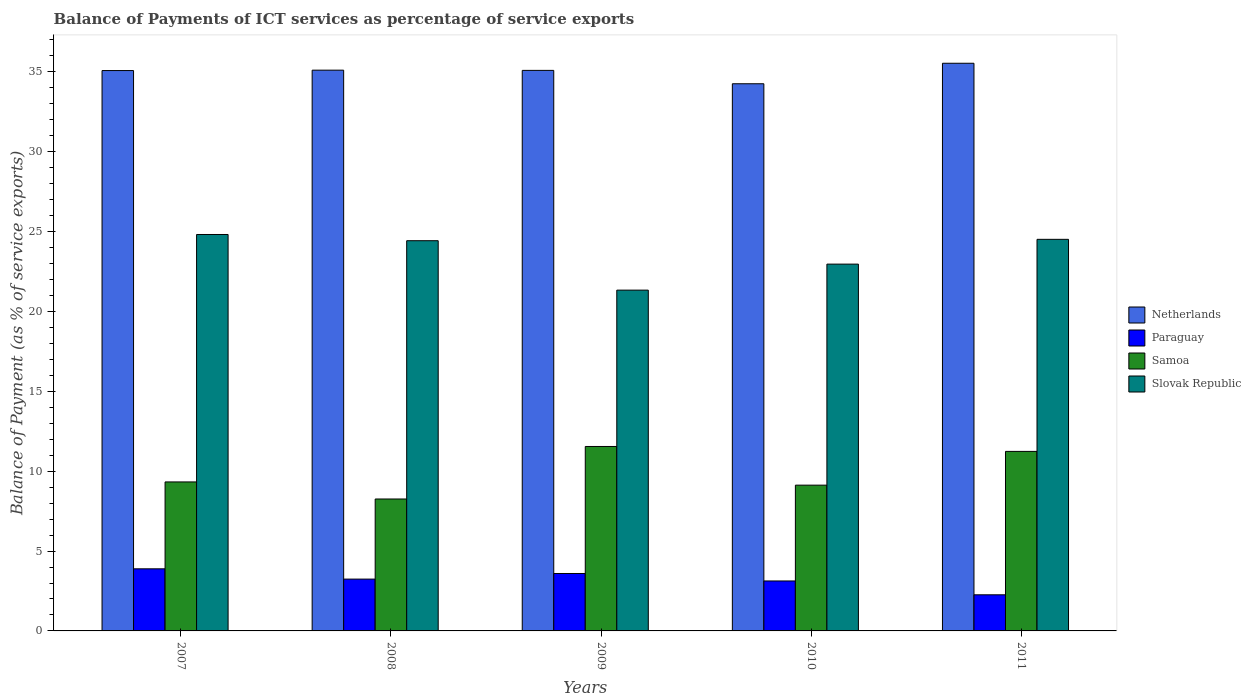How many different coloured bars are there?
Provide a short and direct response. 4. How many groups of bars are there?
Your answer should be very brief. 5. Are the number of bars per tick equal to the number of legend labels?
Provide a succinct answer. Yes. How many bars are there on the 1st tick from the left?
Give a very brief answer. 4. How many bars are there on the 1st tick from the right?
Make the answer very short. 4. In how many cases, is the number of bars for a given year not equal to the number of legend labels?
Ensure brevity in your answer.  0. What is the balance of payments of ICT services in Paraguay in 2011?
Provide a succinct answer. 2.26. Across all years, what is the maximum balance of payments of ICT services in Netherlands?
Your answer should be compact. 35.54. Across all years, what is the minimum balance of payments of ICT services in Paraguay?
Your answer should be compact. 2.26. What is the total balance of payments of ICT services in Slovak Republic in the graph?
Make the answer very short. 118.06. What is the difference between the balance of payments of ICT services in Samoa in 2008 and that in 2010?
Offer a terse response. -0.87. What is the difference between the balance of payments of ICT services in Paraguay in 2010 and the balance of payments of ICT services in Netherlands in 2009?
Keep it short and to the point. -31.96. What is the average balance of payments of ICT services in Samoa per year?
Your response must be concise. 9.9. In the year 2007, what is the difference between the balance of payments of ICT services in Paraguay and balance of payments of ICT services in Slovak Republic?
Your answer should be compact. -20.93. In how many years, is the balance of payments of ICT services in Samoa greater than 1 %?
Your response must be concise. 5. What is the ratio of the balance of payments of ICT services in Paraguay in 2007 to that in 2011?
Offer a very short reply. 1.72. Is the balance of payments of ICT services in Netherlands in 2007 less than that in 2008?
Provide a succinct answer. Yes. Is the difference between the balance of payments of ICT services in Paraguay in 2009 and 2011 greater than the difference between the balance of payments of ICT services in Slovak Republic in 2009 and 2011?
Your response must be concise. Yes. What is the difference between the highest and the second highest balance of payments of ICT services in Paraguay?
Keep it short and to the point. 0.29. What is the difference between the highest and the lowest balance of payments of ICT services in Slovak Republic?
Your response must be concise. 3.48. Is the sum of the balance of payments of ICT services in Slovak Republic in 2010 and 2011 greater than the maximum balance of payments of ICT services in Samoa across all years?
Keep it short and to the point. Yes. Is it the case that in every year, the sum of the balance of payments of ICT services in Slovak Republic and balance of payments of ICT services in Paraguay is greater than the sum of balance of payments of ICT services in Netherlands and balance of payments of ICT services in Samoa?
Make the answer very short. No. What does the 4th bar from the left in 2011 represents?
Provide a succinct answer. Slovak Republic. What does the 3rd bar from the right in 2008 represents?
Provide a short and direct response. Paraguay. Is it the case that in every year, the sum of the balance of payments of ICT services in Netherlands and balance of payments of ICT services in Samoa is greater than the balance of payments of ICT services in Paraguay?
Ensure brevity in your answer.  Yes. Are all the bars in the graph horizontal?
Provide a succinct answer. No. How many years are there in the graph?
Provide a succinct answer. 5. Are the values on the major ticks of Y-axis written in scientific E-notation?
Make the answer very short. No. Does the graph contain any zero values?
Offer a very short reply. No. How many legend labels are there?
Provide a succinct answer. 4. How are the legend labels stacked?
Provide a succinct answer. Vertical. What is the title of the graph?
Your answer should be very brief. Balance of Payments of ICT services as percentage of service exports. What is the label or title of the X-axis?
Provide a succinct answer. Years. What is the label or title of the Y-axis?
Offer a terse response. Balance of Payment (as % of service exports). What is the Balance of Payment (as % of service exports) in Netherlands in 2007?
Provide a short and direct response. 35.08. What is the Balance of Payment (as % of service exports) of Paraguay in 2007?
Your answer should be compact. 3.89. What is the Balance of Payment (as % of service exports) of Samoa in 2007?
Your answer should be very brief. 9.33. What is the Balance of Payment (as % of service exports) in Slovak Republic in 2007?
Your response must be concise. 24.82. What is the Balance of Payment (as % of service exports) of Netherlands in 2008?
Your response must be concise. 35.11. What is the Balance of Payment (as % of service exports) in Paraguay in 2008?
Offer a terse response. 3.24. What is the Balance of Payment (as % of service exports) of Samoa in 2008?
Make the answer very short. 8.26. What is the Balance of Payment (as % of service exports) of Slovak Republic in 2008?
Make the answer very short. 24.43. What is the Balance of Payment (as % of service exports) of Netherlands in 2009?
Provide a short and direct response. 35.09. What is the Balance of Payment (as % of service exports) of Paraguay in 2009?
Ensure brevity in your answer.  3.59. What is the Balance of Payment (as % of service exports) of Samoa in 2009?
Offer a terse response. 11.55. What is the Balance of Payment (as % of service exports) of Slovak Republic in 2009?
Provide a short and direct response. 21.33. What is the Balance of Payment (as % of service exports) of Netherlands in 2010?
Provide a short and direct response. 34.25. What is the Balance of Payment (as % of service exports) of Paraguay in 2010?
Your answer should be very brief. 3.13. What is the Balance of Payment (as % of service exports) in Samoa in 2010?
Ensure brevity in your answer.  9.13. What is the Balance of Payment (as % of service exports) of Slovak Republic in 2010?
Offer a very short reply. 22.96. What is the Balance of Payment (as % of service exports) of Netherlands in 2011?
Offer a terse response. 35.54. What is the Balance of Payment (as % of service exports) in Paraguay in 2011?
Your answer should be compact. 2.26. What is the Balance of Payment (as % of service exports) in Samoa in 2011?
Your answer should be very brief. 11.24. What is the Balance of Payment (as % of service exports) in Slovak Republic in 2011?
Your response must be concise. 24.51. Across all years, what is the maximum Balance of Payment (as % of service exports) in Netherlands?
Make the answer very short. 35.54. Across all years, what is the maximum Balance of Payment (as % of service exports) of Paraguay?
Your answer should be very brief. 3.89. Across all years, what is the maximum Balance of Payment (as % of service exports) of Samoa?
Offer a terse response. 11.55. Across all years, what is the maximum Balance of Payment (as % of service exports) of Slovak Republic?
Offer a terse response. 24.82. Across all years, what is the minimum Balance of Payment (as % of service exports) in Netherlands?
Offer a terse response. 34.25. Across all years, what is the minimum Balance of Payment (as % of service exports) in Paraguay?
Keep it short and to the point. 2.26. Across all years, what is the minimum Balance of Payment (as % of service exports) in Samoa?
Provide a succinct answer. 8.26. Across all years, what is the minimum Balance of Payment (as % of service exports) in Slovak Republic?
Offer a very short reply. 21.33. What is the total Balance of Payment (as % of service exports) of Netherlands in the graph?
Give a very brief answer. 175.07. What is the total Balance of Payment (as % of service exports) in Paraguay in the graph?
Ensure brevity in your answer.  16.11. What is the total Balance of Payment (as % of service exports) in Samoa in the graph?
Make the answer very short. 49.5. What is the total Balance of Payment (as % of service exports) in Slovak Republic in the graph?
Offer a very short reply. 118.06. What is the difference between the Balance of Payment (as % of service exports) of Netherlands in 2007 and that in 2008?
Offer a terse response. -0.02. What is the difference between the Balance of Payment (as % of service exports) of Paraguay in 2007 and that in 2008?
Provide a short and direct response. 0.64. What is the difference between the Balance of Payment (as % of service exports) in Samoa in 2007 and that in 2008?
Provide a short and direct response. 1.07. What is the difference between the Balance of Payment (as % of service exports) in Slovak Republic in 2007 and that in 2008?
Offer a very short reply. 0.39. What is the difference between the Balance of Payment (as % of service exports) of Netherlands in 2007 and that in 2009?
Your answer should be very brief. -0.01. What is the difference between the Balance of Payment (as % of service exports) of Paraguay in 2007 and that in 2009?
Offer a terse response. 0.29. What is the difference between the Balance of Payment (as % of service exports) of Samoa in 2007 and that in 2009?
Provide a short and direct response. -2.22. What is the difference between the Balance of Payment (as % of service exports) in Slovak Republic in 2007 and that in 2009?
Offer a very short reply. 3.48. What is the difference between the Balance of Payment (as % of service exports) of Netherlands in 2007 and that in 2010?
Keep it short and to the point. 0.83. What is the difference between the Balance of Payment (as % of service exports) of Paraguay in 2007 and that in 2010?
Your response must be concise. 0.76. What is the difference between the Balance of Payment (as % of service exports) of Samoa in 2007 and that in 2010?
Provide a short and direct response. 0.2. What is the difference between the Balance of Payment (as % of service exports) of Slovak Republic in 2007 and that in 2010?
Your answer should be very brief. 1.85. What is the difference between the Balance of Payment (as % of service exports) in Netherlands in 2007 and that in 2011?
Provide a succinct answer. -0.46. What is the difference between the Balance of Payment (as % of service exports) of Paraguay in 2007 and that in 2011?
Your answer should be compact. 1.63. What is the difference between the Balance of Payment (as % of service exports) of Samoa in 2007 and that in 2011?
Keep it short and to the point. -1.91. What is the difference between the Balance of Payment (as % of service exports) of Slovak Republic in 2007 and that in 2011?
Your response must be concise. 0.3. What is the difference between the Balance of Payment (as % of service exports) of Netherlands in 2008 and that in 2009?
Your answer should be very brief. 0.01. What is the difference between the Balance of Payment (as % of service exports) of Paraguay in 2008 and that in 2009?
Offer a very short reply. -0.35. What is the difference between the Balance of Payment (as % of service exports) in Samoa in 2008 and that in 2009?
Offer a very short reply. -3.29. What is the difference between the Balance of Payment (as % of service exports) of Slovak Republic in 2008 and that in 2009?
Provide a short and direct response. 3.09. What is the difference between the Balance of Payment (as % of service exports) in Netherlands in 2008 and that in 2010?
Your response must be concise. 0.85. What is the difference between the Balance of Payment (as % of service exports) in Paraguay in 2008 and that in 2010?
Give a very brief answer. 0.12. What is the difference between the Balance of Payment (as % of service exports) in Samoa in 2008 and that in 2010?
Your answer should be very brief. -0.87. What is the difference between the Balance of Payment (as % of service exports) in Slovak Republic in 2008 and that in 2010?
Ensure brevity in your answer.  1.47. What is the difference between the Balance of Payment (as % of service exports) in Netherlands in 2008 and that in 2011?
Offer a terse response. -0.43. What is the difference between the Balance of Payment (as % of service exports) in Paraguay in 2008 and that in 2011?
Make the answer very short. 0.98. What is the difference between the Balance of Payment (as % of service exports) of Samoa in 2008 and that in 2011?
Make the answer very short. -2.98. What is the difference between the Balance of Payment (as % of service exports) of Slovak Republic in 2008 and that in 2011?
Make the answer very short. -0.09. What is the difference between the Balance of Payment (as % of service exports) in Netherlands in 2009 and that in 2010?
Give a very brief answer. 0.84. What is the difference between the Balance of Payment (as % of service exports) in Paraguay in 2009 and that in 2010?
Your answer should be very brief. 0.47. What is the difference between the Balance of Payment (as % of service exports) in Samoa in 2009 and that in 2010?
Your response must be concise. 2.42. What is the difference between the Balance of Payment (as % of service exports) in Slovak Republic in 2009 and that in 2010?
Make the answer very short. -1.63. What is the difference between the Balance of Payment (as % of service exports) of Netherlands in 2009 and that in 2011?
Your response must be concise. -0.45. What is the difference between the Balance of Payment (as % of service exports) of Paraguay in 2009 and that in 2011?
Keep it short and to the point. 1.33. What is the difference between the Balance of Payment (as % of service exports) in Samoa in 2009 and that in 2011?
Provide a short and direct response. 0.31. What is the difference between the Balance of Payment (as % of service exports) of Slovak Republic in 2009 and that in 2011?
Keep it short and to the point. -3.18. What is the difference between the Balance of Payment (as % of service exports) in Netherlands in 2010 and that in 2011?
Offer a terse response. -1.28. What is the difference between the Balance of Payment (as % of service exports) in Paraguay in 2010 and that in 2011?
Provide a succinct answer. 0.87. What is the difference between the Balance of Payment (as % of service exports) of Samoa in 2010 and that in 2011?
Provide a short and direct response. -2.11. What is the difference between the Balance of Payment (as % of service exports) of Slovak Republic in 2010 and that in 2011?
Make the answer very short. -1.55. What is the difference between the Balance of Payment (as % of service exports) in Netherlands in 2007 and the Balance of Payment (as % of service exports) in Paraguay in 2008?
Your answer should be very brief. 31.84. What is the difference between the Balance of Payment (as % of service exports) of Netherlands in 2007 and the Balance of Payment (as % of service exports) of Samoa in 2008?
Keep it short and to the point. 26.82. What is the difference between the Balance of Payment (as % of service exports) of Netherlands in 2007 and the Balance of Payment (as % of service exports) of Slovak Republic in 2008?
Your answer should be very brief. 10.65. What is the difference between the Balance of Payment (as % of service exports) in Paraguay in 2007 and the Balance of Payment (as % of service exports) in Samoa in 2008?
Offer a very short reply. -4.37. What is the difference between the Balance of Payment (as % of service exports) of Paraguay in 2007 and the Balance of Payment (as % of service exports) of Slovak Republic in 2008?
Your answer should be very brief. -20.54. What is the difference between the Balance of Payment (as % of service exports) of Samoa in 2007 and the Balance of Payment (as % of service exports) of Slovak Republic in 2008?
Give a very brief answer. -15.1. What is the difference between the Balance of Payment (as % of service exports) of Netherlands in 2007 and the Balance of Payment (as % of service exports) of Paraguay in 2009?
Offer a very short reply. 31.49. What is the difference between the Balance of Payment (as % of service exports) in Netherlands in 2007 and the Balance of Payment (as % of service exports) in Samoa in 2009?
Provide a succinct answer. 23.53. What is the difference between the Balance of Payment (as % of service exports) of Netherlands in 2007 and the Balance of Payment (as % of service exports) of Slovak Republic in 2009?
Provide a short and direct response. 13.75. What is the difference between the Balance of Payment (as % of service exports) in Paraguay in 2007 and the Balance of Payment (as % of service exports) in Samoa in 2009?
Your response must be concise. -7.66. What is the difference between the Balance of Payment (as % of service exports) of Paraguay in 2007 and the Balance of Payment (as % of service exports) of Slovak Republic in 2009?
Your response must be concise. -17.45. What is the difference between the Balance of Payment (as % of service exports) in Samoa in 2007 and the Balance of Payment (as % of service exports) in Slovak Republic in 2009?
Provide a short and direct response. -12.01. What is the difference between the Balance of Payment (as % of service exports) in Netherlands in 2007 and the Balance of Payment (as % of service exports) in Paraguay in 2010?
Provide a succinct answer. 31.95. What is the difference between the Balance of Payment (as % of service exports) in Netherlands in 2007 and the Balance of Payment (as % of service exports) in Samoa in 2010?
Provide a short and direct response. 25.96. What is the difference between the Balance of Payment (as % of service exports) of Netherlands in 2007 and the Balance of Payment (as % of service exports) of Slovak Republic in 2010?
Provide a succinct answer. 12.12. What is the difference between the Balance of Payment (as % of service exports) in Paraguay in 2007 and the Balance of Payment (as % of service exports) in Samoa in 2010?
Your answer should be compact. -5.24. What is the difference between the Balance of Payment (as % of service exports) of Paraguay in 2007 and the Balance of Payment (as % of service exports) of Slovak Republic in 2010?
Offer a very short reply. -19.08. What is the difference between the Balance of Payment (as % of service exports) of Samoa in 2007 and the Balance of Payment (as % of service exports) of Slovak Republic in 2010?
Offer a very short reply. -13.64. What is the difference between the Balance of Payment (as % of service exports) of Netherlands in 2007 and the Balance of Payment (as % of service exports) of Paraguay in 2011?
Provide a succinct answer. 32.82. What is the difference between the Balance of Payment (as % of service exports) of Netherlands in 2007 and the Balance of Payment (as % of service exports) of Samoa in 2011?
Your answer should be very brief. 23.84. What is the difference between the Balance of Payment (as % of service exports) of Netherlands in 2007 and the Balance of Payment (as % of service exports) of Slovak Republic in 2011?
Your response must be concise. 10.57. What is the difference between the Balance of Payment (as % of service exports) in Paraguay in 2007 and the Balance of Payment (as % of service exports) in Samoa in 2011?
Your answer should be compact. -7.35. What is the difference between the Balance of Payment (as % of service exports) in Paraguay in 2007 and the Balance of Payment (as % of service exports) in Slovak Republic in 2011?
Give a very brief answer. -20.63. What is the difference between the Balance of Payment (as % of service exports) in Samoa in 2007 and the Balance of Payment (as % of service exports) in Slovak Republic in 2011?
Offer a terse response. -15.19. What is the difference between the Balance of Payment (as % of service exports) of Netherlands in 2008 and the Balance of Payment (as % of service exports) of Paraguay in 2009?
Your answer should be very brief. 31.51. What is the difference between the Balance of Payment (as % of service exports) of Netherlands in 2008 and the Balance of Payment (as % of service exports) of Samoa in 2009?
Give a very brief answer. 23.56. What is the difference between the Balance of Payment (as % of service exports) of Netherlands in 2008 and the Balance of Payment (as % of service exports) of Slovak Republic in 2009?
Provide a succinct answer. 13.77. What is the difference between the Balance of Payment (as % of service exports) of Paraguay in 2008 and the Balance of Payment (as % of service exports) of Samoa in 2009?
Offer a terse response. -8.3. What is the difference between the Balance of Payment (as % of service exports) in Paraguay in 2008 and the Balance of Payment (as % of service exports) in Slovak Republic in 2009?
Ensure brevity in your answer.  -18.09. What is the difference between the Balance of Payment (as % of service exports) in Samoa in 2008 and the Balance of Payment (as % of service exports) in Slovak Republic in 2009?
Your answer should be very brief. -13.08. What is the difference between the Balance of Payment (as % of service exports) in Netherlands in 2008 and the Balance of Payment (as % of service exports) in Paraguay in 2010?
Your response must be concise. 31.98. What is the difference between the Balance of Payment (as % of service exports) of Netherlands in 2008 and the Balance of Payment (as % of service exports) of Samoa in 2010?
Make the answer very short. 25.98. What is the difference between the Balance of Payment (as % of service exports) in Netherlands in 2008 and the Balance of Payment (as % of service exports) in Slovak Republic in 2010?
Provide a succinct answer. 12.14. What is the difference between the Balance of Payment (as % of service exports) of Paraguay in 2008 and the Balance of Payment (as % of service exports) of Samoa in 2010?
Your answer should be very brief. -5.88. What is the difference between the Balance of Payment (as % of service exports) in Paraguay in 2008 and the Balance of Payment (as % of service exports) in Slovak Republic in 2010?
Provide a succinct answer. -19.72. What is the difference between the Balance of Payment (as % of service exports) of Samoa in 2008 and the Balance of Payment (as % of service exports) of Slovak Republic in 2010?
Your answer should be very brief. -14.7. What is the difference between the Balance of Payment (as % of service exports) of Netherlands in 2008 and the Balance of Payment (as % of service exports) of Paraguay in 2011?
Offer a very short reply. 32.84. What is the difference between the Balance of Payment (as % of service exports) in Netherlands in 2008 and the Balance of Payment (as % of service exports) in Samoa in 2011?
Keep it short and to the point. 23.87. What is the difference between the Balance of Payment (as % of service exports) of Netherlands in 2008 and the Balance of Payment (as % of service exports) of Slovak Republic in 2011?
Offer a terse response. 10.59. What is the difference between the Balance of Payment (as % of service exports) in Paraguay in 2008 and the Balance of Payment (as % of service exports) in Samoa in 2011?
Keep it short and to the point. -7.99. What is the difference between the Balance of Payment (as % of service exports) of Paraguay in 2008 and the Balance of Payment (as % of service exports) of Slovak Republic in 2011?
Ensure brevity in your answer.  -21.27. What is the difference between the Balance of Payment (as % of service exports) of Samoa in 2008 and the Balance of Payment (as % of service exports) of Slovak Republic in 2011?
Ensure brevity in your answer.  -16.26. What is the difference between the Balance of Payment (as % of service exports) in Netherlands in 2009 and the Balance of Payment (as % of service exports) in Paraguay in 2010?
Make the answer very short. 31.96. What is the difference between the Balance of Payment (as % of service exports) of Netherlands in 2009 and the Balance of Payment (as % of service exports) of Samoa in 2010?
Offer a terse response. 25.97. What is the difference between the Balance of Payment (as % of service exports) in Netherlands in 2009 and the Balance of Payment (as % of service exports) in Slovak Republic in 2010?
Provide a succinct answer. 12.13. What is the difference between the Balance of Payment (as % of service exports) of Paraguay in 2009 and the Balance of Payment (as % of service exports) of Samoa in 2010?
Your answer should be compact. -5.53. What is the difference between the Balance of Payment (as % of service exports) of Paraguay in 2009 and the Balance of Payment (as % of service exports) of Slovak Republic in 2010?
Offer a very short reply. -19.37. What is the difference between the Balance of Payment (as % of service exports) in Samoa in 2009 and the Balance of Payment (as % of service exports) in Slovak Republic in 2010?
Offer a very short reply. -11.42. What is the difference between the Balance of Payment (as % of service exports) of Netherlands in 2009 and the Balance of Payment (as % of service exports) of Paraguay in 2011?
Your answer should be compact. 32.83. What is the difference between the Balance of Payment (as % of service exports) of Netherlands in 2009 and the Balance of Payment (as % of service exports) of Samoa in 2011?
Keep it short and to the point. 23.85. What is the difference between the Balance of Payment (as % of service exports) of Netherlands in 2009 and the Balance of Payment (as % of service exports) of Slovak Republic in 2011?
Offer a very short reply. 10.58. What is the difference between the Balance of Payment (as % of service exports) in Paraguay in 2009 and the Balance of Payment (as % of service exports) in Samoa in 2011?
Provide a short and direct response. -7.64. What is the difference between the Balance of Payment (as % of service exports) in Paraguay in 2009 and the Balance of Payment (as % of service exports) in Slovak Republic in 2011?
Offer a terse response. -20.92. What is the difference between the Balance of Payment (as % of service exports) in Samoa in 2009 and the Balance of Payment (as % of service exports) in Slovak Republic in 2011?
Your answer should be very brief. -12.97. What is the difference between the Balance of Payment (as % of service exports) of Netherlands in 2010 and the Balance of Payment (as % of service exports) of Paraguay in 2011?
Your response must be concise. 31.99. What is the difference between the Balance of Payment (as % of service exports) of Netherlands in 2010 and the Balance of Payment (as % of service exports) of Samoa in 2011?
Your answer should be very brief. 23.02. What is the difference between the Balance of Payment (as % of service exports) of Netherlands in 2010 and the Balance of Payment (as % of service exports) of Slovak Republic in 2011?
Your response must be concise. 9.74. What is the difference between the Balance of Payment (as % of service exports) of Paraguay in 2010 and the Balance of Payment (as % of service exports) of Samoa in 2011?
Ensure brevity in your answer.  -8.11. What is the difference between the Balance of Payment (as % of service exports) of Paraguay in 2010 and the Balance of Payment (as % of service exports) of Slovak Republic in 2011?
Make the answer very short. -21.39. What is the difference between the Balance of Payment (as % of service exports) of Samoa in 2010 and the Balance of Payment (as % of service exports) of Slovak Republic in 2011?
Provide a short and direct response. -15.39. What is the average Balance of Payment (as % of service exports) of Netherlands per year?
Give a very brief answer. 35.01. What is the average Balance of Payment (as % of service exports) of Paraguay per year?
Keep it short and to the point. 3.22. What is the average Balance of Payment (as % of service exports) in Samoa per year?
Offer a terse response. 9.9. What is the average Balance of Payment (as % of service exports) of Slovak Republic per year?
Make the answer very short. 23.61. In the year 2007, what is the difference between the Balance of Payment (as % of service exports) of Netherlands and Balance of Payment (as % of service exports) of Paraguay?
Your answer should be compact. 31.19. In the year 2007, what is the difference between the Balance of Payment (as % of service exports) in Netherlands and Balance of Payment (as % of service exports) in Samoa?
Provide a succinct answer. 25.75. In the year 2007, what is the difference between the Balance of Payment (as % of service exports) in Netherlands and Balance of Payment (as % of service exports) in Slovak Republic?
Offer a very short reply. 10.26. In the year 2007, what is the difference between the Balance of Payment (as % of service exports) of Paraguay and Balance of Payment (as % of service exports) of Samoa?
Ensure brevity in your answer.  -5.44. In the year 2007, what is the difference between the Balance of Payment (as % of service exports) of Paraguay and Balance of Payment (as % of service exports) of Slovak Republic?
Provide a short and direct response. -20.93. In the year 2007, what is the difference between the Balance of Payment (as % of service exports) in Samoa and Balance of Payment (as % of service exports) in Slovak Republic?
Offer a terse response. -15.49. In the year 2008, what is the difference between the Balance of Payment (as % of service exports) of Netherlands and Balance of Payment (as % of service exports) of Paraguay?
Your answer should be compact. 31.86. In the year 2008, what is the difference between the Balance of Payment (as % of service exports) of Netherlands and Balance of Payment (as % of service exports) of Samoa?
Your response must be concise. 26.85. In the year 2008, what is the difference between the Balance of Payment (as % of service exports) in Netherlands and Balance of Payment (as % of service exports) in Slovak Republic?
Ensure brevity in your answer.  10.68. In the year 2008, what is the difference between the Balance of Payment (as % of service exports) in Paraguay and Balance of Payment (as % of service exports) in Samoa?
Your answer should be very brief. -5.02. In the year 2008, what is the difference between the Balance of Payment (as % of service exports) of Paraguay and Balance of Payment (as % of service exports) of Slovak Republic?
Ensure brevity in your answer.  -21.19. In the year 2008, what is the difference between the Balance of Payment (as % of service exports) of Samoa and Balance of Payment (as % of service exports) of Slovak Republic?
Provide a succinct answer. -16.17. In the year 2009, what is the difference between the Balance of Payment (as % of service exports) in Netherlands and Balance of Payment (as % of service exports) in Paraguay?
Provide a short and direct response. 31.5. In the year 2009, what is the difference between the Balance of Payment (as % of service exports) in Netherlands and Balance of Payment (as % of service exports) in Samoa?
Offer a terse response. 23.55. In the year 2009, what is the difference between the Balance of Payment (as % of service exports) of Netherlands and Balance of Payment (as % of service exports) of Slovak Republic?
Provide a succinct answer. 13.76. In the year 2009, what is the difference between the Balance of Payment (as % of service exports) of Paraguay and Balance of Payment (as % of service exports) of Samoa?
Offer a very short reply. -7.95. In the year 2009, what is the difference between the Balance of Payment (as % of service exports) in Paraguay and Balance of Payment (as % of service exports) in Slovak Republic?
Provide a short and direct response. -17.74. In the year 2009, what is the difference between the Balance of Payment (as % of service exports) in Samoa and Balance of Payment (as % of service exports) in Slovak Republic?
Keep it short and to the point. -9.79. In the year 2010, what is the difference between the Balance of Payment (as % of service exports) of Netherlands and Balance of Payment (as % of service exports) of Paraguay?
Ensure brevity in your answer.  31.13. In the year 2010, what is the difference between the Balance of Payment (as % of service exports) of Netherlands and Balance of Payment (as % of service exports) of Samoa?
Ensure brevity in your answer.  25.13. In the year 2010, what is the difference between the Balance of Payment (as % of service exports) in Netherlands and Balance of Payment (as % of service exports) in Slovak Republic?
Provide a short and direct response. 11.29. In the year 2010, what is the difference between the Balance of Payment (as % of service exports) of Paraguay and Balance of Payment (as % of service exports) of Samoa?
Your answer should be compact. -6. In the year 2010, what is the difference between the Balance of Payment (as % of service exports) of Paraguay and Balance of Payment (as % of service exports) of Slovak Republic?
Give a very brief answer. -19.84. In the year 2010, what is the difference between the Balance of Payment (as % of service exports) of Samoa and Balance of Payment (as % of service exports) of Slovak Republic?
Keep it short and to the point. -13.84. In the year 2011, what is the difference between the Balance of Payment (as % of service exports) of Netherlands and Balance of Payment (as % of service exports) of Paraguay?
Ensure brevity in your answer.  33.28. In the year 2011, what is the difference between the Balance of Payment (as % of service exports) of Netherlands and Balance of Payment (as % of service exports) of Samoa?
Your answer should be very brief. 24.3. In the year 2011, what is the difference between the Balance of Payment (as % of service exports) in Netherlands and Balance of Payment (as % of service exports) in Slovak Republic?
Your answer should be compact. 11.02. In the year 2011, what is the difference between the Balance of Payment (as % of service exports) of Paraguay and Balance of Payment (as % of service exports) of Samoa?
Your answer should be compact. -8.98. In the year 2011, what is the difference between the Balance of Payment (as % of service exports) of Paraguay and Balance of Payment (as % of service exports) of Slovak Republic?
Offer a terse response. -22.25. In the year 2011, what is the difference between the Balance of Payment (as % of service exports) in Samoa and Balance of Payment (as % of service exports) in Slovak Republic?
Keep it short and to the point. -13.28. What is the ratio of the Balance of Payment (as % of service exports) of Netherlands in 2007 to that in 2008?
Keep it short and to the point. 1. What is the ratio of the Balance of Payment (as % of service exports) in Paraguay in 2007 to that in 2008?
Offer a very short reply. 1.2. What is the ratio of the Balance of Payment (as % of service exports) in Samoa in 2007 to that in 2008?
Your answer should be compact. 1.13. What is the ratio of the Balance of Payment (as % of service exports) of Slovak Republic in 2007 to that in 2008?
Keep it short and to the point. 1.02. What is the ratio of the Balance of Payment (as % of service exports) of Paraguay in 2007 to that in 2009?
Your answer should be compact. 1.08. What is the ratio of the Balance of Payment (as % of service exports) of Samoa in 2007 to that in 2009?
Keep it short and to the point. 0.81. What is the ratio of the Balance of Payment (as % of service exports) in Slovak Republic in 2007 to that in 2009?
Your answer should be compact. 1.16. What is the ratio of the Balance of Payment (as % of service exports) in Netherlands in 2007 to that in 2010?
Provide a succinct answer. 1.02. What is the ratio of the Balance of Payment (as % of service exports) in Paraguay in 2007 to that in 2010?
Make the answer very short. 1.24. What is the ratio of the Balance of Payment (as % of service exports) in Samoa in 2007 to that in 2010?
Your answer should be very brief. 1.02. What is the ratio of the Balance of Payment (as % of service exports) in Slovak Republic in 2007 to that in 2010?
Your answer should be compact. 1.08. What is the ratio of the Balance of Payment (as % of service exports) of Netherlands in 2007 to that in 2011?
Offer a terse response. 0.99. What is the ratio of the Balance of Payment (as % of service exports) of Paraguay in 2007 to that in 2011?
Keep it short and to the point. 1.72. What is the ratio of the Balance of Payment (as % of service exports) of Samoa in 2007 to that in 2011?
Offer a terse response. 0.83. What is the ratio of the Balance of Payment (as % of service exports) of Slovak Republic in 2007 to that in 2011?
Your response must be concise. 1.01. What is the ratio of the Balance of Payment (as % of service exports) of Paraguay in 2008 to that in 2009?
Provide a succinct answer. 0.9. What is the ratio of the Balance of Payment (as % of service exports) in Samoa in 2008 to that in 2009?
Give a very brief answer. 0.72. What is the ratio of the Balance of Payment (as % of service exports) in Slovak Republic in 2008 to that in 2009?
Offer a terse response. 1.15. What is the ratio of the Balance of Payment (as % of service exports) of Netherlands in 2008 to that in 2010?
Your answer should be compact. 1.02. What is the ratio of the Balance of Payment (as % of service exports) of Paraguay in 2008 to that in 2010?
Give a very brief answer. 1.04. What is the ratio of the Balance of Payment (as % of service exports) of Samoa in 2008 to that in 2010?
Your response must be concise. 0.91. What is the ratio of the Balance of Payment (as % of service exports) of Slovak Republic in 2008 to that in 2010?
Ensure brevity in your answer.  1.06. What is the ratio of the Balance of Payment (as % of service exports) of Paraguay in 2008 to that in 2011?
Make the answer very short. 1.43. What is the ratio of the Balance of Payment (as % of service exports) in Samoa in 2008 to that in 2011?
Make the answer very short. 0.73. What is the ratio of the Balance of Payment (as % of service exports) in Slovak Republic in 2008 to that in 2011?
Provide a succinct answer. 1. What is the ratio of the Balance of Payment (as % of service exports) of Netherlands in 2009 to that in 2010?
Make the answer very short. 1.02. What is the ratio of the Balance of Payment (as % of service exports) of Paraguay in 2009 to that in 2010?
Provide a short and direct response. 1.15. What is the ratio of the Balance of Payment (as % of service exports) of Samoa in 2009 to that in 2010?
Offer a very short reply. 1.27. What is the ratio of the Balance of Payment (as % of service exports) of Slovak Republic in 2009 to that in 2010?
Provide a short and direct response. 0.93. What is the ratio of the Balance of Payment (as % of service exports) in Netherlands in 2009 to that in 2011?
Offer a very short reply. 0.99. What is the ratio of the Balance of Payment (as % of service exports) of Paraguay in 2009 to that in 2011?
Your answer should be compact. 1.59. What is the ratio of the Balance of Payment (as % of service exports) in Samoa in 2009 to that in 2011?
Your answer should be compact. 1.03. What is the ratio of the Balance of Payment (as % of service exports) of Slovak Republic in 2009 to that in 2011?
Your answer should be very brief. 0.87. What is the ratio of the Balance of Payment (as % of service exports) of Netherlands in 2010 to that in 2011?
Your answer should be very brief. 0.96. What is the ratio of the Balance of Payment (as % of service exports) in Paraguay in 2010 to that in 2011?
Offer a very short reply. 1.38. What is the ratio of the Balance of Payment (as % of service exports) of Samoa in 2010 to that in 2011?
Provide a succinct answer. 0.81. What is the ratio of the Balance of Payment (as % of service exports) in Slovak Republic in 2010 to that in 2011?
Give a very brief answer. 0.94. What is the difference between the highest and the second highest Balance of Payment (as % of service exports) in Netherlands?
Offer a very short reply. 0.43. What is the difference between the highest and the second highest Balance of Payment (as % of service exports) of Paraguay?
Offer a very short reply. 0.29. What is the difference between the highest and the second highest Balance of Payment (as % of service exports) in Samoa?
Provide a short and direct response. 0.31. What is the difference between the highest and the second highest Balance of Payment (as % of service exports) of Slovak Republic?
Make the answer very short. 0.3. What is the difference between the highest and the lowest Balance of Payment (as % of service exports) of Netherlands?
Make the answer very short. 1.28. What is the difference between the highest and the lowest Balance of Payment (as % of service exports) in Paraguay?
Offer a terse response. 1.63. What is the difference between the highest and the lowest Balance of Payment (as % of service exports) of Samoa?
Your answer should be compact. 3.29. What is the difference between the highest and the lowest Balance of Payment (as % of service exports) of Slovak Republic?
Offer a very short reply. 3.48. 